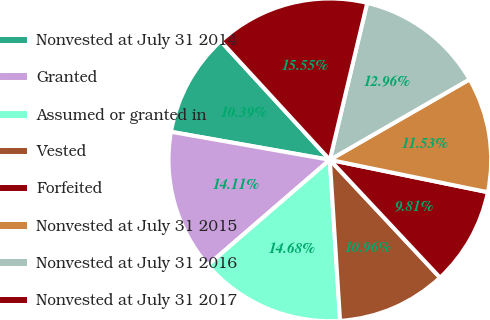Convert chart to OTSL. <chart><loc_0><loc_0><loc_500><loc_500><pie_chart><fcel>Nonvested at July 31 2014<fcel>Granted<fcel>Assumed or granted in<fcel>Vested<fcel>Forfeited<fcel>Nonvested at July 31 2015<fcel>Nonvested at July 31 2016<fcel>Nonvested at July 31 2017<nl><fcel>10.39%<fcel>14.11%<fcel>14.68%<fcel>10.96%<fcel>9.81%<fcel>11.53%<fcel>12.96%<fcel>15.55%<nl></chart> 